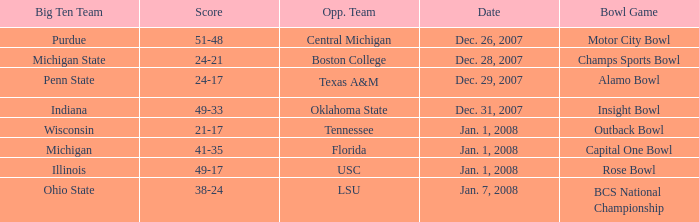Who was the rival team in the match with a score of 21-17? Tennessee. 